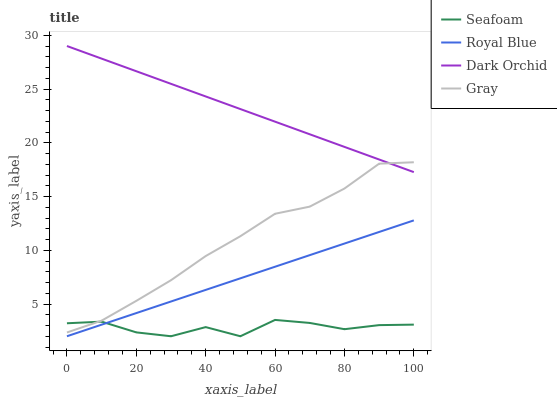Does Seafoam have the minimum area under the curve?
Answer yes or no. Yes. Does Dark Orchid have the maximum area under the curve?
Answer yes or no. Yes. Does Dark Orchid have the minimum area under the curve?
Answer yes or no. No. Does Seafoam have the maximum area under the curve?
Answer yes or no. No. Is Royal Blue the smoothest?
Answer yes or no. Yes. Is Seafoam the roughest?
Answer yes or no. Yes. Is Dark Orchid the smoothest?
Answer yes or no. No. Is Dark Orchid the roughest?
Answer yes or no. No. Does Royal Blue have the lowest value?
Answer yes or no. Yes. Does Dark Orchid have the lowest value?
Answer yes or no. No. Does Dark Orchid have the highest value?
Answer yes or no. Yes. Does Seafoam have the highest value?
Answer yes or no. No. Is Royal Blue less than Dark Orchid?
Answer yes or no. Yes. Is Dark Orchid greater than Royal Blue?
Answer yes or no. Yes. Does Royal Blue intersect Seafoam?
Answer yes or no. Yes. Is Royal Blue less than Seafoam?
Answer yes or no. No. Is Royal Blue greater than Seafoam?
Answer yes or no. No. Does Royal Blue intersect Dark Orchid?
Answer yes or no. No. 